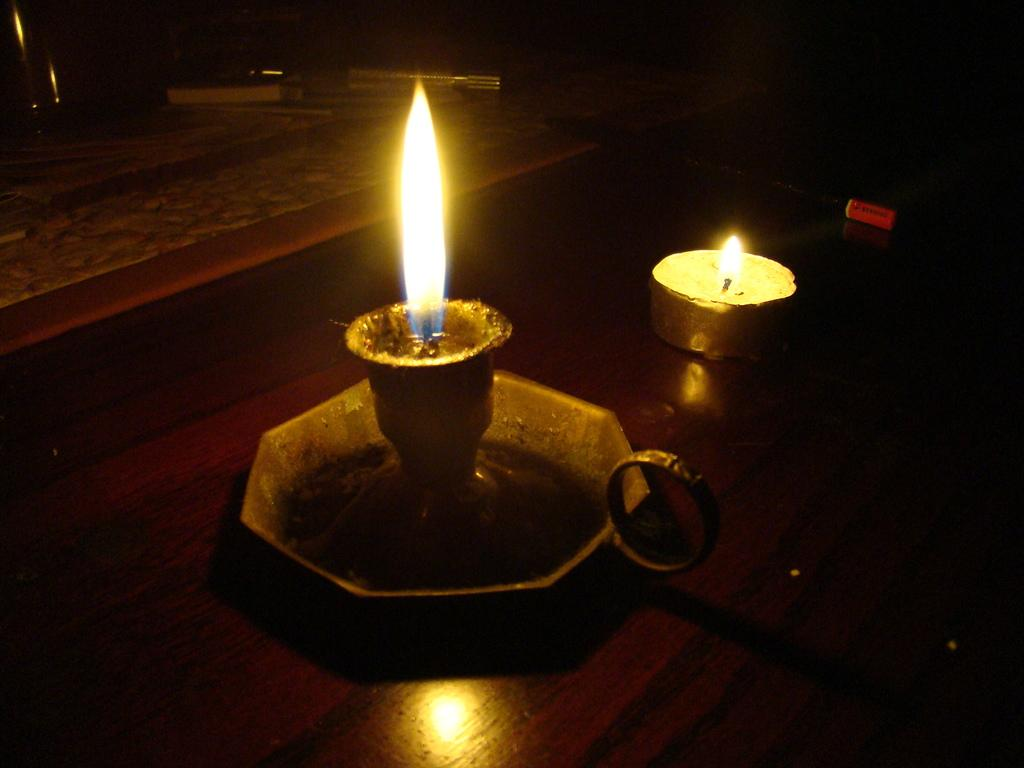How many candles are visible in the image? There are two candles in the image. Where are the candles located? The candles are on a surface. What else can be seen around the candles? There are other objects present around the candles. What type of stamp can be seen on the candles in the image? There is no stamp present on the candles in the image. How does the zephyr affect the candles in the image? There is no mention of a zephyr or any wind in the image, so it cannot affect the candles. 